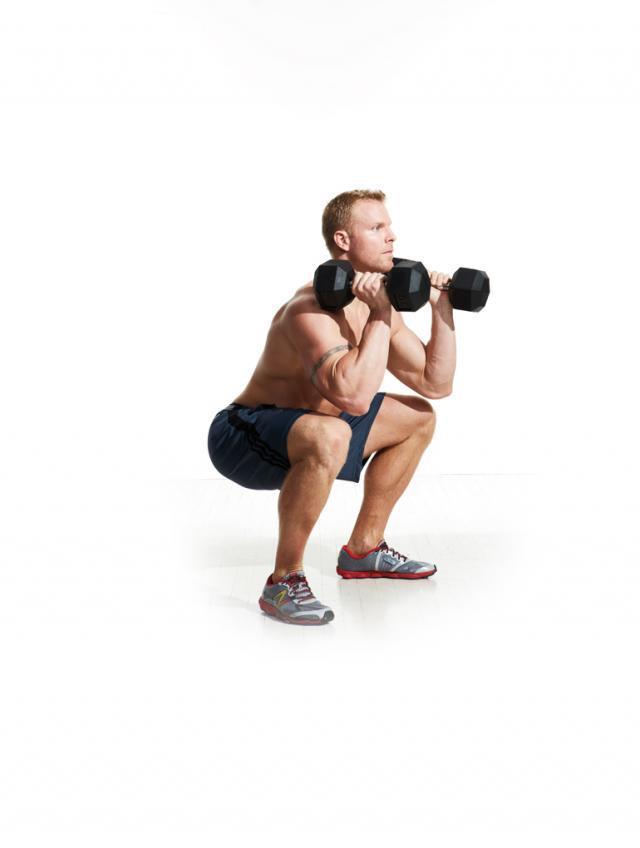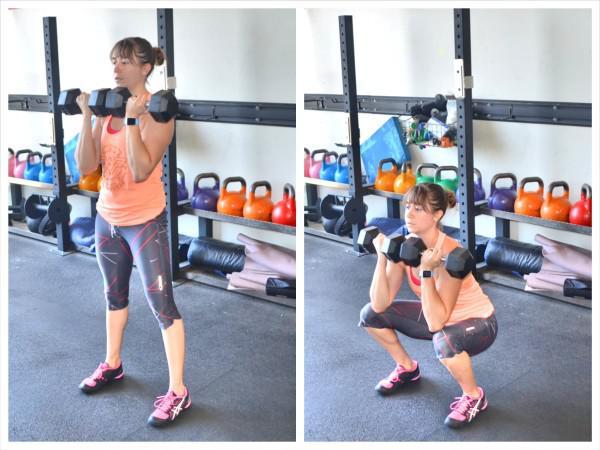The first image is the image on the left, the second image is the image on the right. Given the left and right images, does the statement "A single person is lifting weights in each of the images." hold true? Answer yes or no. No. The first image is the image on the left, the second image is the image on the right. For the images displayed, is the sentence "A woman is lifting weights in a squat position." factually correct? Answer yes or no. Yes. 